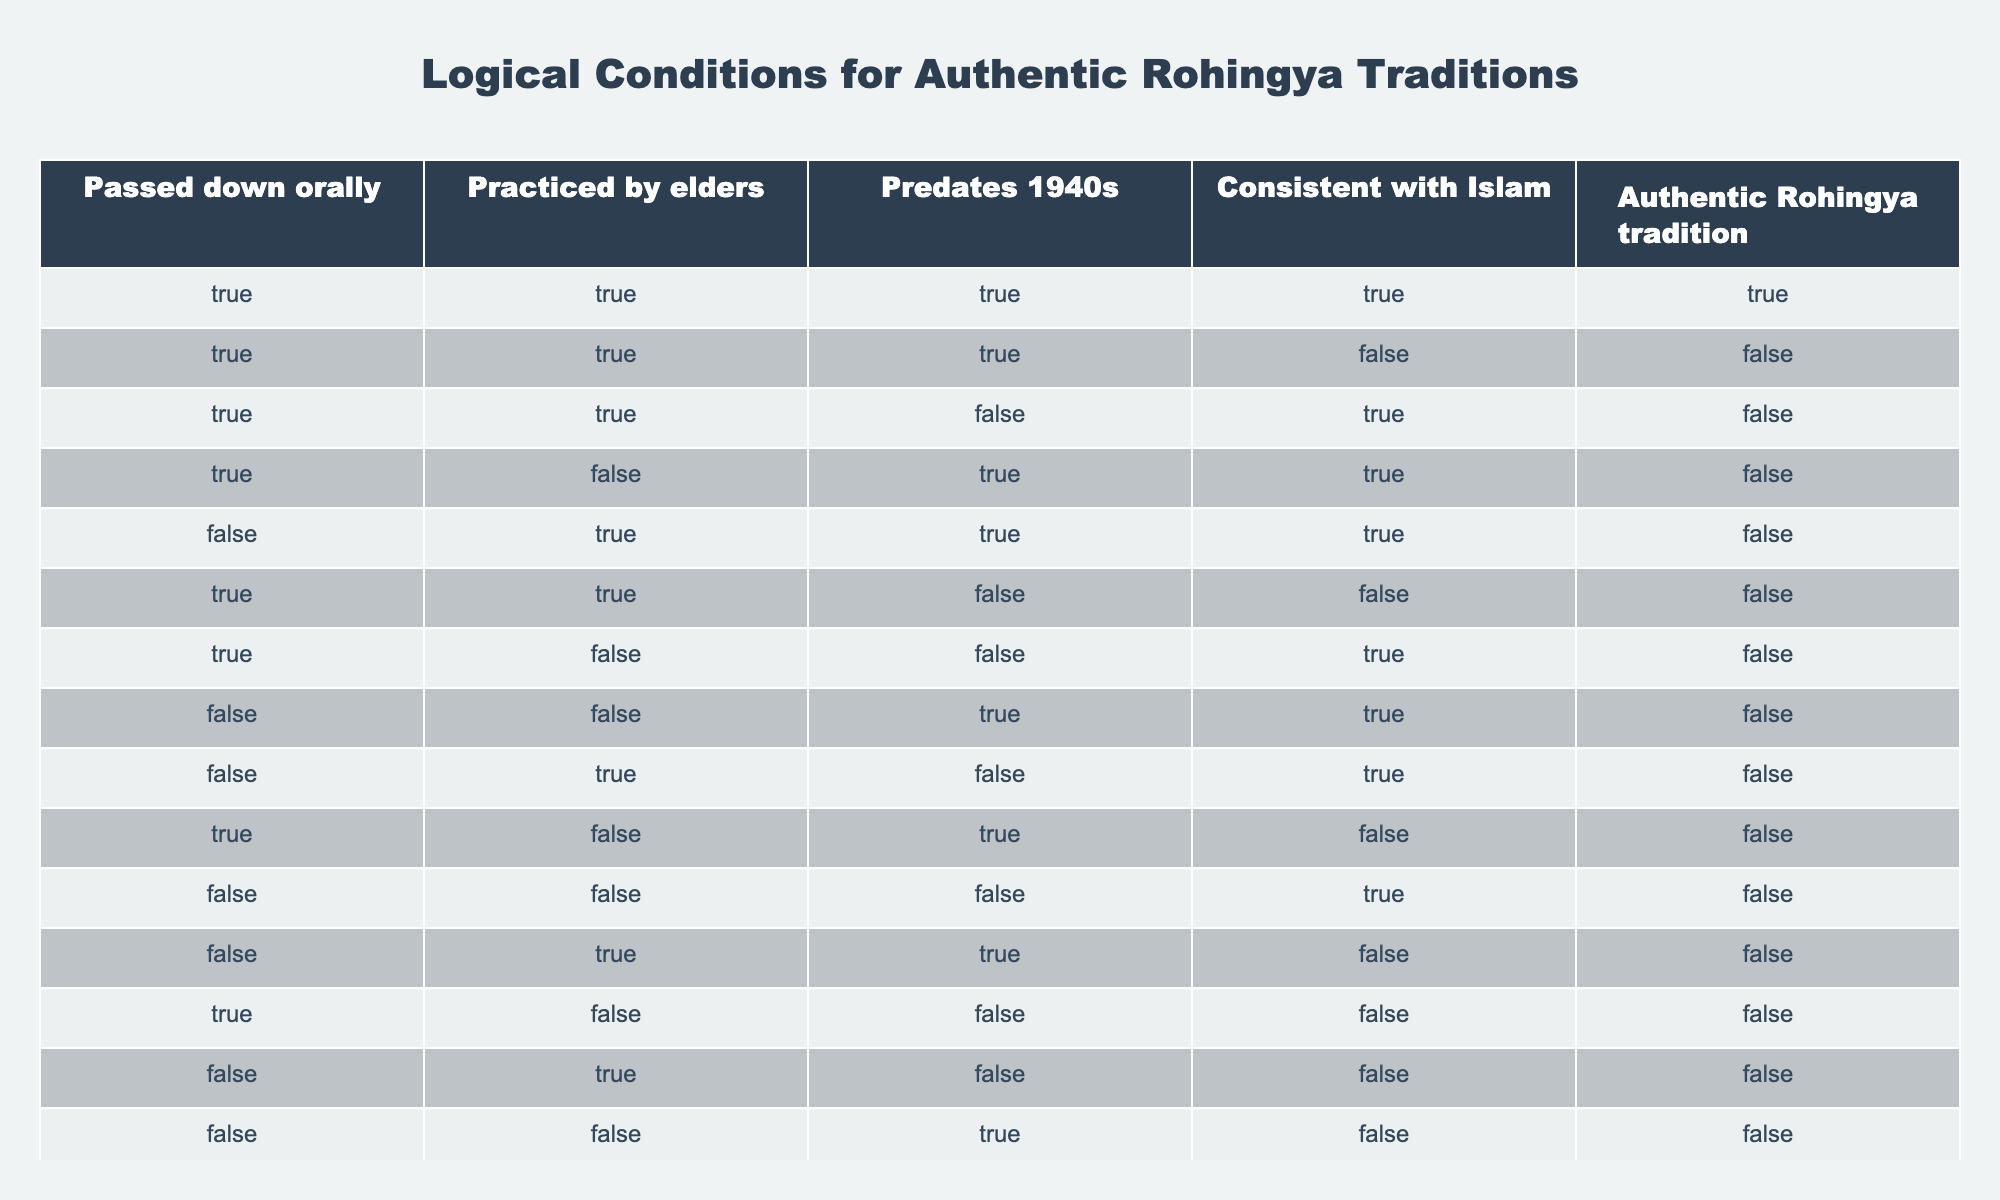What percentage of practices are both consistent with Islam and passed down orally? To find the percentage, I need to identify the number of practices that are both consistent with Islam (TRUE) and passed down orally (TRUE). In the table, these are the cases: 1st row (TRUE), 2nd row (TRUE), 3rd row (TRUE), 4th row (FALSE), 5th row (FALSE), and 6th row (TRUE) totaling 4. There are 16 total cases, so the percentage is (4/16) * 100 = 25%.
Answer: 25% Are there any traditions that are practiced by elders but not consistent with Islam? By scanning the table, I can see that in rows 2 and 5, the tradition is practiced by elders (TRUE) but not consistent with Islam (FALSE). This confirms there are traditions fitting this criteria.
Answer: Yes What is the total number of traditions that are both practiced by elders and predate the 1940s? I will count the number of traditions marked as TRUE for both "Practiced by elders" and "Predates 1940s". Looking at the table, rows 1, 2, 5, and 9 all meet this condition for a total of 4 traditions.
Answer: 4 Is there any tradition that is authentic and also not practiced by elders? I will check the rows to see if "Authentic Rohingya tradition" is TRUE and "Practiced by elders" is FALSE at the same time. In this case, no rows meet this criteria since the only row that is authentic (1st) shows it is practiced by elders (TRUE).
Answer: No How many traditions are passed down orally but do not predate the 1940s? I will identify the rows where "Passed down orally" is TRUE and "Predates 1940s" is FALSE. These conditions are met in rows 3, 6, 7, 11, 12, and 14, totaling 6 traditions.
Answer: 6 What is the number of traditions that are authentic but not passed down orally? To answer this, I will look for rows where "Authentic Rohingya tradition" is TRUE while "Passed down orally" is FALSE. In this case, there are no such rows, as all authentic entries also have oral passing down as TRUE.
Answer: 0 Are all traditions that predate the 1940s also consistent with Islam? I need to check the rows where "Predates 1940s" is TRUE and see if "Consistent with Islam" is also TRUE. Rows 1, 2, 4, 5, and 8 are True for the first condition, but only rows 1, 2, and 4 (3 rows) follow both criteria, so not all entries are consistent with Islam.
Answer: No What is the maximum number of conditions a traditional practice can meet to be considered authentic? The maximum number of conditions is determined by the conditions that qualify as TRUE in a given row. The first row meets all four conditions (TRUE for all). Therefore, the maximum number is 4.
Answer: 4 